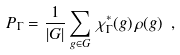<formula> <loc_0><loc_0><loc_500><loc_500>P _ { \Gamma } = \frac { 1 } { | G | } \sum _ { g \in G } \, \chi _ { \Gamma } ^ { * } ( g ) \, \rho ( g ) \ ,</formula> 